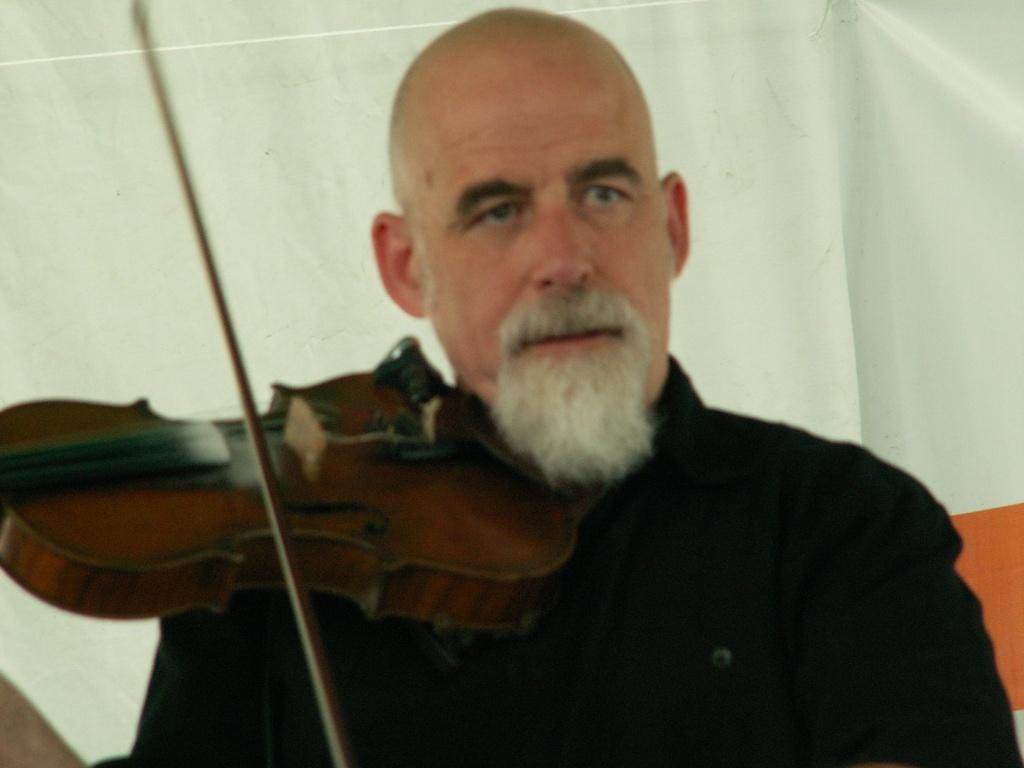Who is the main subject in the image? There is a man in the image. What is the man holding in his hands? The man is holding a violin in his hands. What can be seen in the background of the image? There is a banner in the background of the image. What type of popcorn is the man eating while playing the violin in the image? There is no popcorn present in the image, and the man is not eating while playing the violin. 